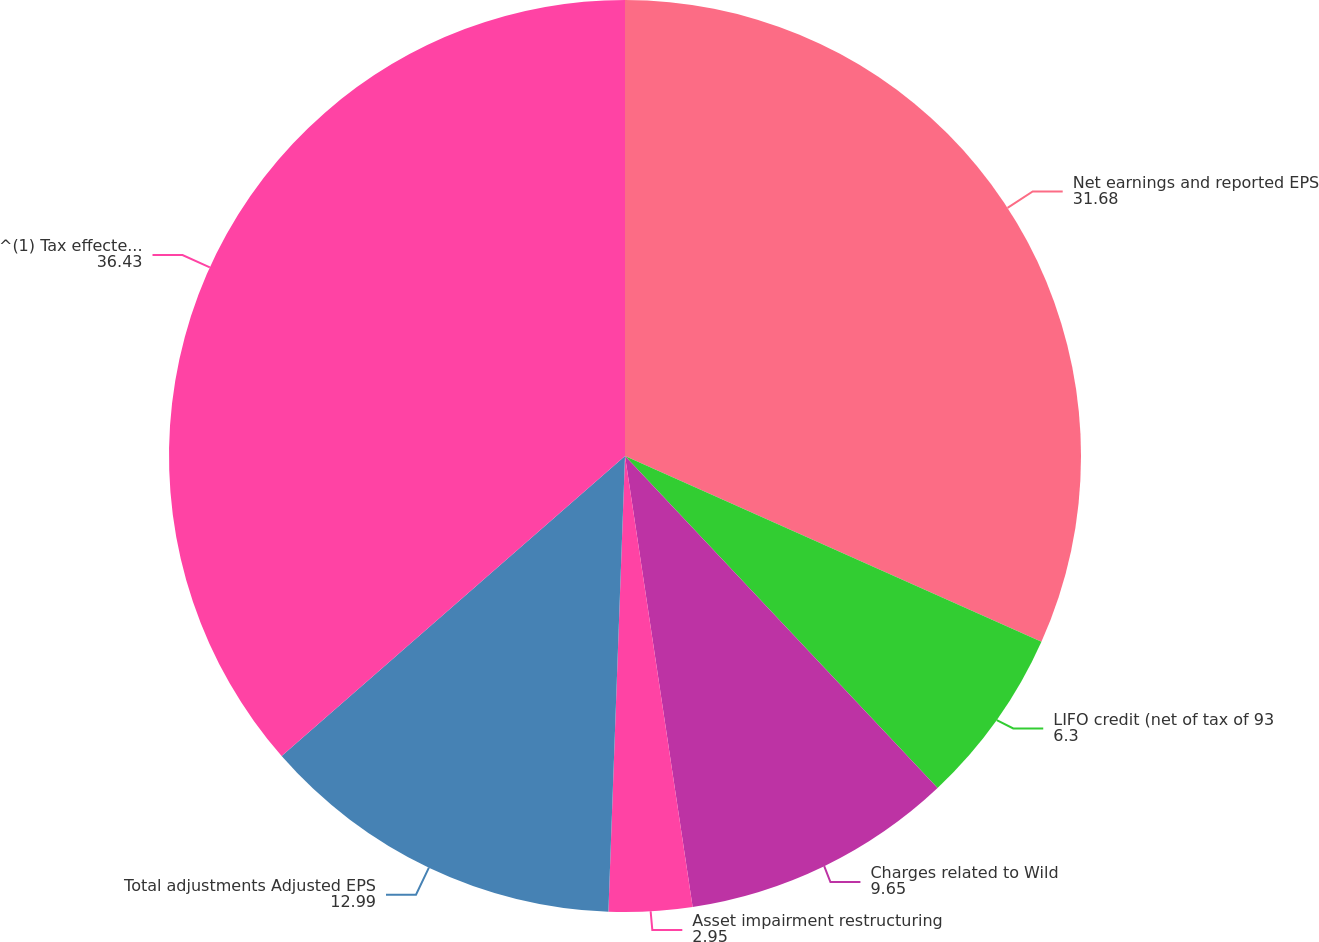Convert chart to OTSL. <chart><loc_0><loc_0><loc_500><loc_500><pie_chart><fcel>Net earnings and reported EPS<fcel>LIFO credit (net of tax of 93<fcel>Charges related to Wild<fcel>Asset impairment restructuring<fcel>Total adjustments Adjusted EPS<fcel>^(1) Tax effected using the<nl><fcel>31.68%<fcel>6.3%<fcel>9.65%<fcel>2.95%<fcel>12.99%<fcel>36.43%<nl></chart> 